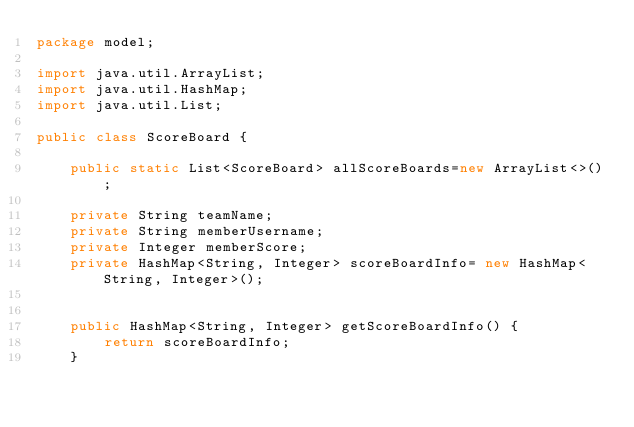Convert code to text. <code><loc_0><loc_0><loc_500><loc_500><_Java_>package model;

import java.util.ArrayList;
import java.util.HashMap;
import java.util.List;

public class ScoreBoard {

    public static List<ScoreBoard> allScoreBoards=new ArrayList<>();

    private String teamName;
    private String memberUsername;
    private Integer memberScore;
    private HashMap<String, Integer> scoreBoardInfo= new HashMap<String, Integer>();


    public HashMap<String, Integer> getScoreBoardInfo() {
        return scoreBoardInfo;
    }</code> 